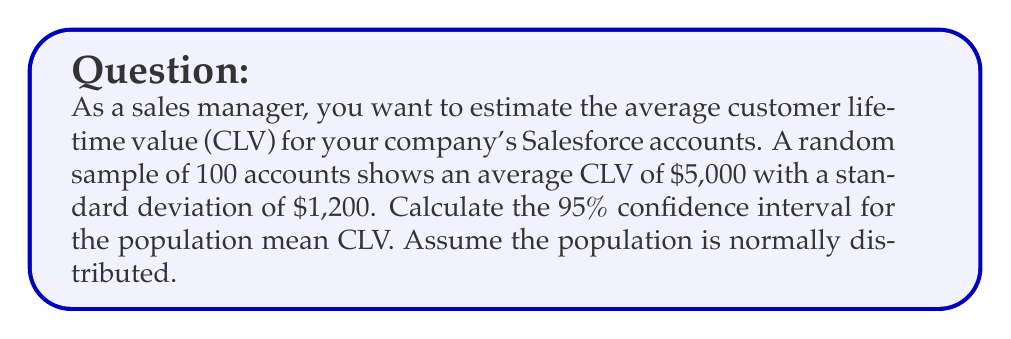Could you help me with this problem? To calculate the confidence interval, we'll follow these steps:

1. Identify the known values:
   - Sample size: $n = 100$
   - Sample mean: $\bar{x} = \$5,000$
   - Sample standard deviation: $s = \$1,200$
   - Confidence level: 95% (α = 0.05)

2. Find the critical value ($z$) for a 95% confidence interval:
   $z = 1.96$ (from the standard normal distribution table)

3. Calculate the standard error of the mean:
   $SE = \frac{s}{\sqrt{n}} = \frac{1200}{\sqrt{100}} = \frac{1200}{10} = 120$

4. Calculate the margin of error:
   $ME = z \times SE = 1.96 \times 120 = 235.20$

5. Construct the confidence interval:
   $CI = \bar{x} \pm ME$
   $CI = 5000 \pm 235.20$
   $CI = (4764.80, 5235.20)$

Therefore, we can be 95% confident that the true population mean CLV falls between $4,764.80 and $5,235.20.
Answer: 95% CI for mean CLV: ($4,764.80, $5,235.20) 